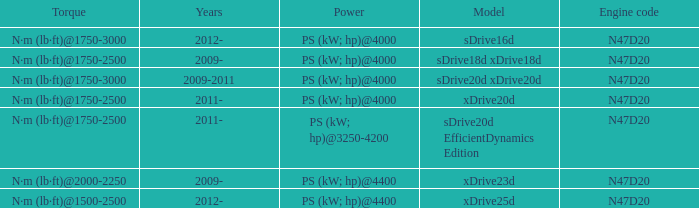What model is the n·m (lb·ft)@1500-2500 torque? Xdrive25d. 